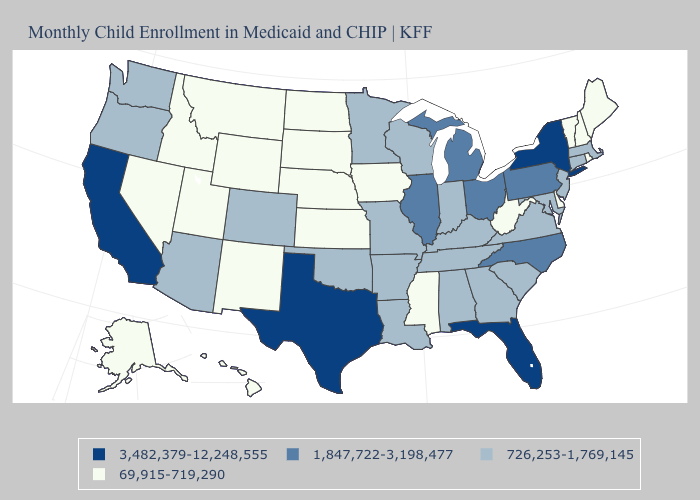Does Rhode Island have the lowest value in the USA?
Concise answer only. Yes. What is the highest value in the USA?
Concise answer only. 3,482,379-12,248,555. Name the states that have a value in the range 69,915-719,290?
Answer briefly. Alaska, Delaware, Hawaii, Idaho, Iowa, Kansas, Maine, Mississippi, Montana, Nebraska, Nevada, New Hampshire, New Mexico, North Dakota, Rhode Island, South Dakota, Utah, Vermont, West Virginia, Wyoming. Which states have the highest value in the USA?
Keep it brief. California, Florida, New York, Texas. Among the states that border Kansas , does Nebraska have the highest value?
Concise answer only. No. Which states hav the highest value in the Northeast?
Answer briefly. New York. Among the states that border Kansas , which have the highest value?
Be succinct. Colorado, Missouri, Oklahoma. What is the value of Wyoming?
Be succinct. 69,915-719,290. What is the lowest value in the West?
Write a very short answer. 69,915-719,290. What is the highest value in the West ?
Quick response, please. 3,482,379-12,248,555. What is the value of Indiana?
Answer briefly. 726,253-1,769,145. What is the value of Missouri?
Give a very brief answer. 726,253-1,769,145. Name the states that have a value in the range 3,482,379-12,248,555?
Concise answer only. California, Florida, New York, Texas. Which states have the lowest value in the MidWest?
Answer briefly. Iowa, Kansas, Nebraska, North Dakota, South Dakota. Does the map have missing data?
Keep it brief. No. 